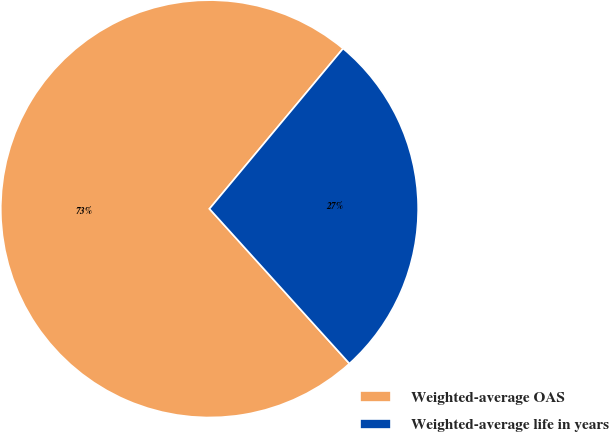Convert chart to OTSL. <chart><loc_0><loc_0><loc_500><loc_500><pie_chart><fcel>Weighted-average OAS<fcel>Weighted-average life in years<nl><fcel>72.76%<fcel>27.24%<nl></chart> 